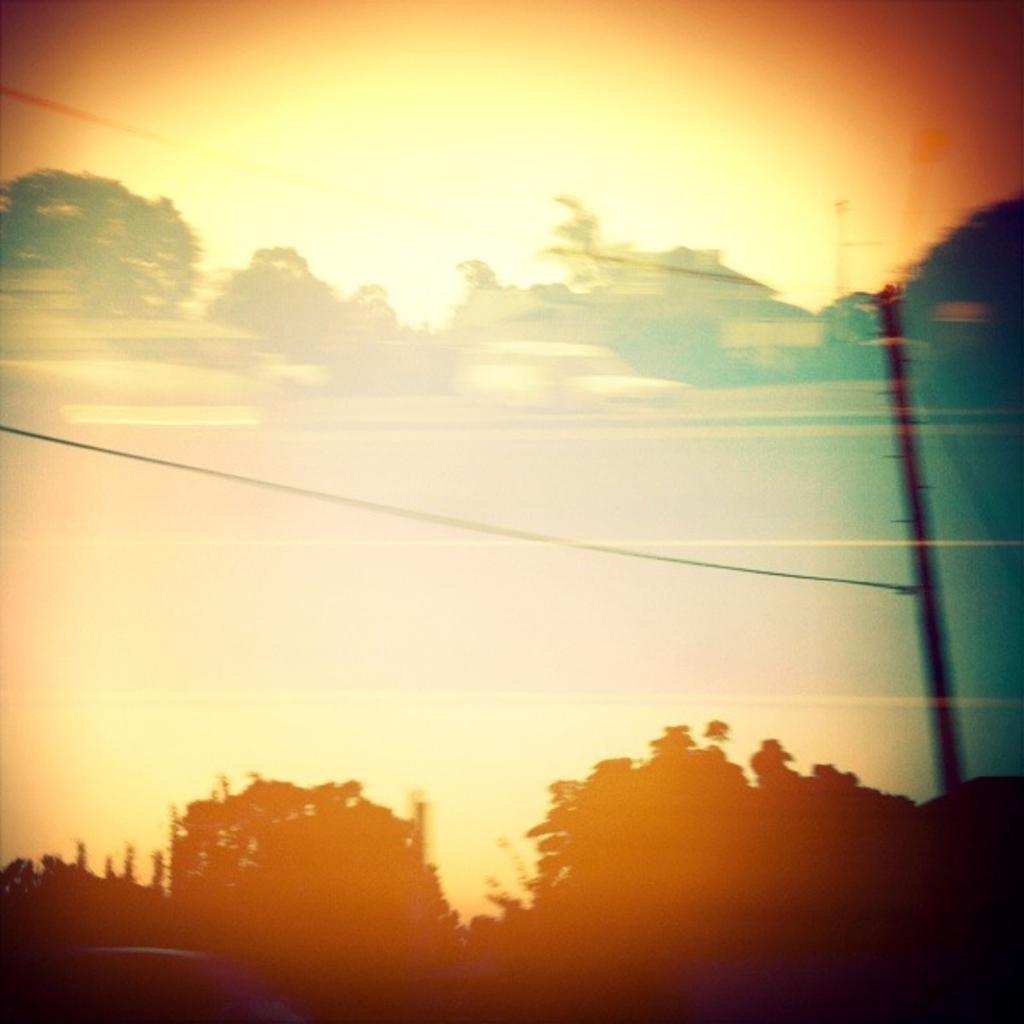What type of vegetation is at the bottom of the image? There are trees at the bottom of the image. What object can be seen on the right side of the image? There is a pole on the right side of the image. What is visible in the background of the image? The sky is visible in the background of the image. What type of bone can be seen on the coast in the image? There is no bone or coast present in the image. What answer is provided by the trees at the bottom of the image? The trees at the bottom of the image do not provide an answer, as they are a natural element and not a source of information or communication. 